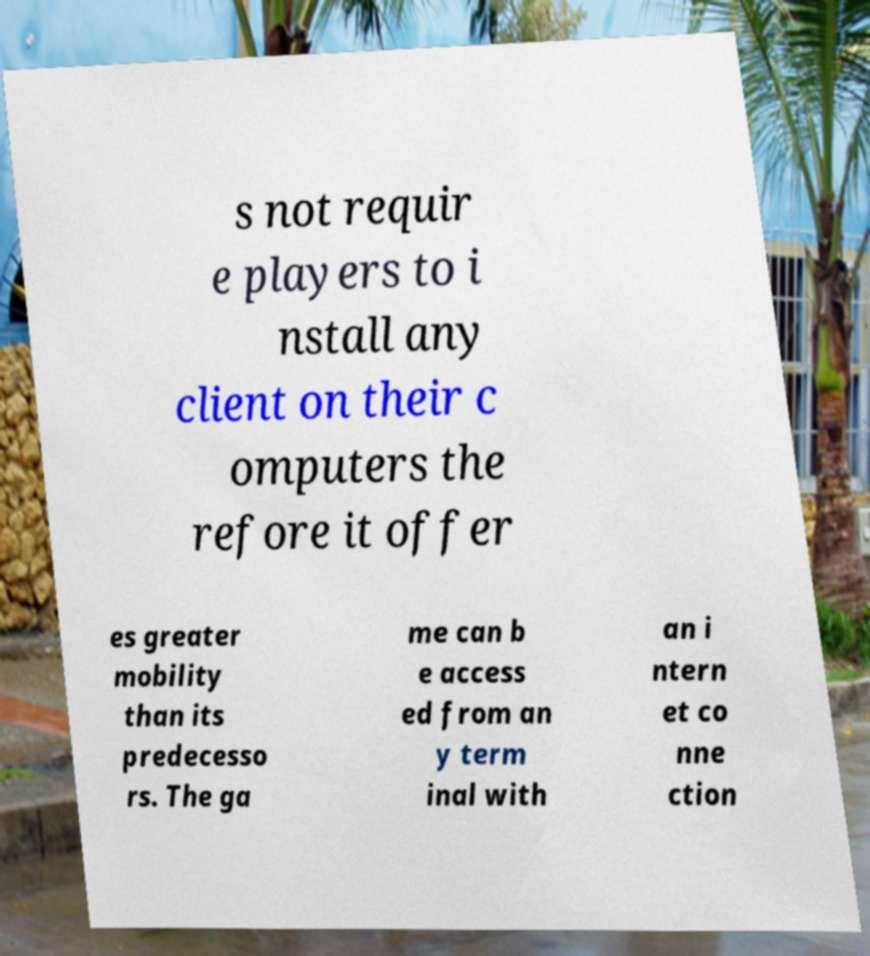Could you assist in decoding the text presented in this image and type it out clearly? s not requir e players to i nstall any client on their c omputers the refore it offer es greater mobility than its predecesso rs. The ga me can b e access ed from an y term inal with an i ntern et co nne ction 